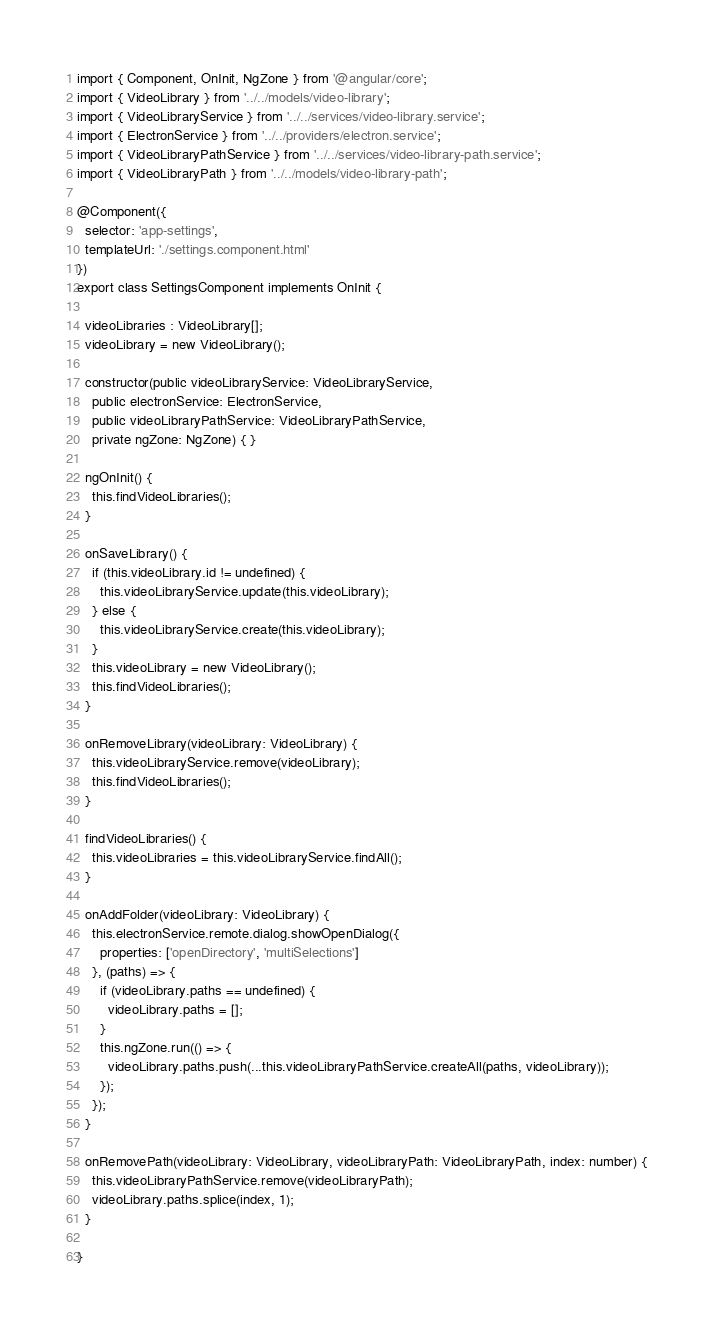<code> <loc_0><loc_0><loc_500><loc_500><_TypeScript_>import { Component, OnInit, NgZone } from '@angular/core';
import { VideoLibrary } from '../../models/video-library';
import { VideoLibraryService } from '../../services/video-library.service';
import { ElectronService } from '../../providers/electron.service';
import { VideoLibraryPathService } from '../../services/video-library-path.service';
import { VideoLibraryPath } from '../../models/video-library-path';

@Component({
  selector: 'app-settings',
  templateUrl: './settings.component.html'
})
export class SettingsComponent implements OnInit {

  videoLibraries : VideoLibrary[];
  videoLibrary = new VideoLibrary();

  constructor(public videoLibraryService: VideoLibraryService,
    public electronService: ElectronService,
    public videoLibraryPathService: VideoLibraryPathService,
    private ngZone: NgZone) { }

  ngOnInit() {
    this.findVideoLibraries();
  }

  onSaveLibrary() {
    if (this.videoLibrary.id != undefined) {
      this.videoLibraryService.update(this.videoLibrary);
    } else {
      this.videoLibraryService.create(this.videoLibrary);
    }
    this.videoLibrary = new VideoLibrary();
    this.findVideoLibraries();
  }

  onRemoveLibrary(videoLibrary: VideoLibrary) {
    this.videoLibraryService.remove(videoLibrary);
    this.findVideoLibraries();
  }

  findVideoLibraries() {
    this.videoLibraries = this.videoLibraryService.findAll();
  }

  onAddFolder(videoLibrary: VideoLibrary) {
    this.electronService.remote.dialog.showOpenDialog({
      properties: ['openDirectory', 'multiSelections']
    }, (paths) => {
      if (videoLibrary.paths == undefined) {
        videoLibrary.paths = [];
      }
      this.ngZone.run(() => {
        videoLibrary.paths.push(...this.videoLibraryPathService.createAll(paths, videoLibrary));
      });
    });
  }

  onRemovePath(videoLibrary: VideoLibrary, videoLibraryPath: VideoLibraryPath, index: number) {
    this.videoLibraryPathService.remove(videoLibraryPath);
    videoLibrary.paths.splice(index, 1);
  }

}
</code> 